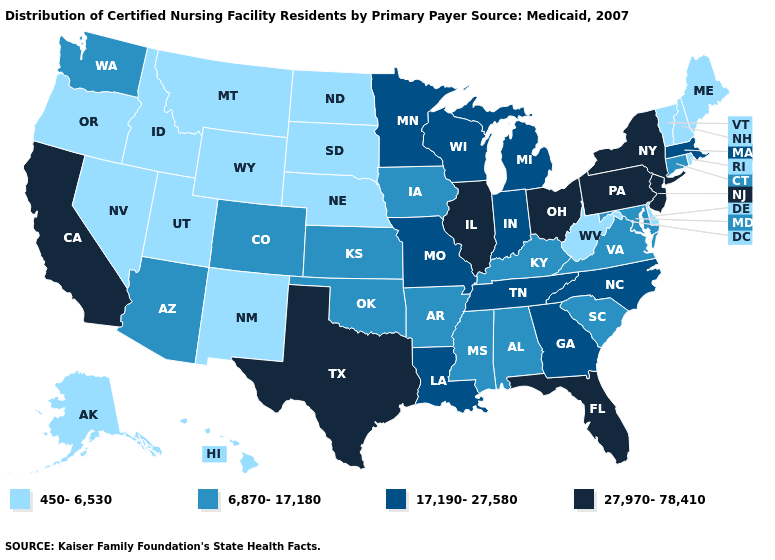What is the value of Wyoming?
Give a very brief answer. 450-6,530. What is the value of Vermont?
Short answer required. 450-6,530. Which states have the lowest value in the South?
Answer briefly. Delaware, West Virginia. Which states have the highest value in the USA?
Quick response, please. California, Florida, Illinois, New Jersey, New York, Ohio, Pennsylvania, Texas. Does Hawaii have the same value as Wisconsin?
Write a very short answer. No. How many symbols are there in the legend?
Keep it brief. 4. What is the value of Colorado?
Quick response, please. 6,870-17,180. Does the map have missing data?
Quick response, please. No. Name the states that have a value in the range 6,870-17,180?
Be succinct. Alabama, Arizona, Arkansas, Colorado, Connecticut, Iowa, Kansas, Kentucky, Maryland, Mississippi, Oklahoma, South Carolina, Virginia, Washington. Does the first symbol in the legend represent the smallest category?
Keep it brief. Yes. Which states hav the highest value in the South?
Quick response, please. Florida, Texas. What is the highest value in the MidWest ?
Write a very short answer. 27,970-78,410. What is the highest value in the MidWest ?
Give a very brief answer. 27,970-78,410. What is the highest value in the Northeast ?
Quick response, please. 27,970-78,410. Among the states that border Florida , which have the lowest value?
Quick response, please. Alabama. 